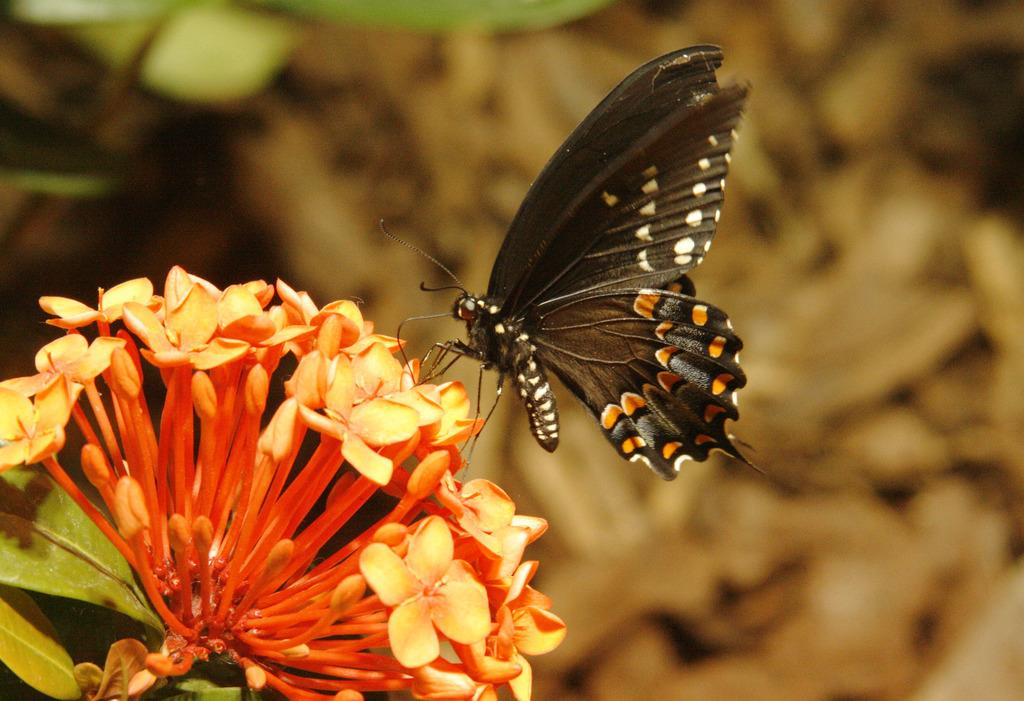What is the main subject of the image? There is a butterfly in the image. Where is the butterfly located in the image? The butterfly is on a flower. Can you describe the background of the image? The background of the image is blurred. What type of vegetable is being held by the butterfly in the image? There is no vegetable present in the image, and the butterfly is not holding anything. 